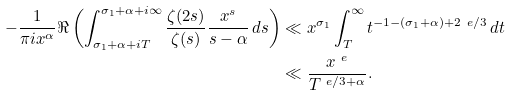<formula> <loc_0><loc_0><loc_500><loc_500>- \frac { 1 } { \pi i x ^ { \alpha } } \Re \left ( \int ^ { \sigma _ { 1 } + \alpha + i \infty } _ { \sigma _ { 1 } + \alpha + i T } { \frac { \zeta ( 2 s ) } { \zeta ( s ) } \frac { x ^ { s } } { s - \alpha } \, d s } \right ) & \ll x ^ { \sigma _ { 1 } } \int ^ { \infty } _ { T } { t ^ { - 1 - ( \sigma _ { 1 } + \alpha ) + 2 \ e / 3 } \, d t } \\ & \ll \frac { x ^ { \ e } } { T ^ { \ e / 3 + \alpha } } .</formula> 